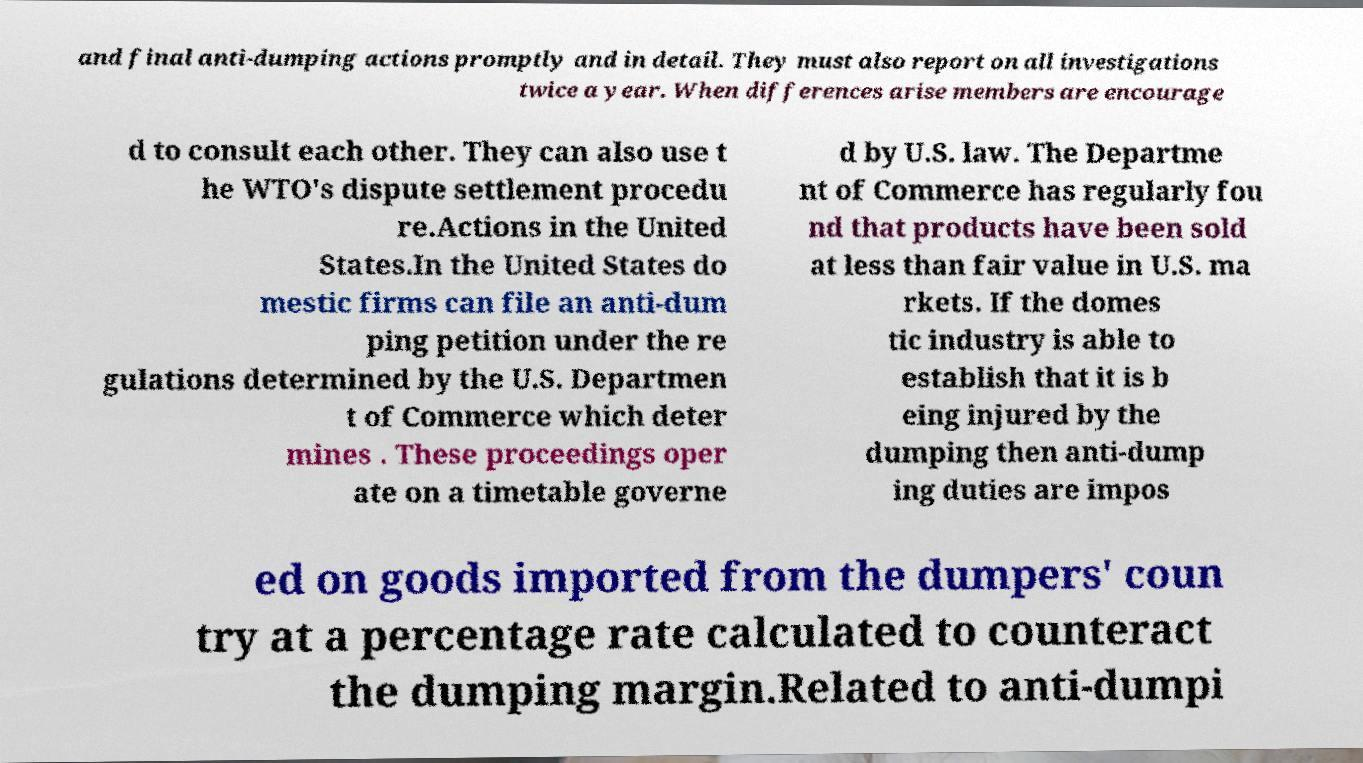There's text embedded in this image that I need extracted. Can you transcribe it verbatim? and final anti-dumping actions promptly and in detail. They must also report on all investigations twice a year. When differences arise members are encourage d to consult each other. They can also use t he WTO's dispute settlement procedu re.Actions in the United States.In the United States do mestic firms can file an anti-dum ping petition under the re gulations determined by the U.S. Departmen t of Commerce which deter mines . These proceedings oper ate on a timetable governe d by U.S. law. The Departme nt of Commerce has regularly fou nd that products have been sold at less than fair value in U.S. ma rkets. If the domes tic industry is able to establish that it is b eing injured by the dumping then anti-dump ing duties are impos ed on goods imported from the dumpers' coun try at a percentage rate calculated to counteract the dumping margin.Related to anti-dumpi 